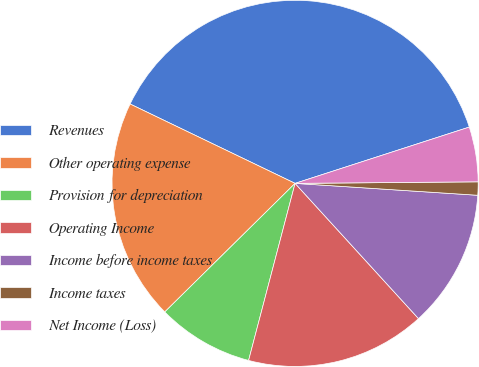Convert chart to OTSL. <chart><loc_0><loc_0><loc_500><loc_500><pie_chart><fcel>Revenues<fcel>Other operating expense<fcel>Provision for depreciation<fcel>Operating Income<fcel>Income before income taxes<fcel>Income taxes<fcel>Net Income (Loss)<nl><fcel>37.89%<fcel>19.53%<fcel>8.52%<fcel>15.86%<fcel>12.19%<fcel>1.17%<fcel>4.84%<nl></chart> 